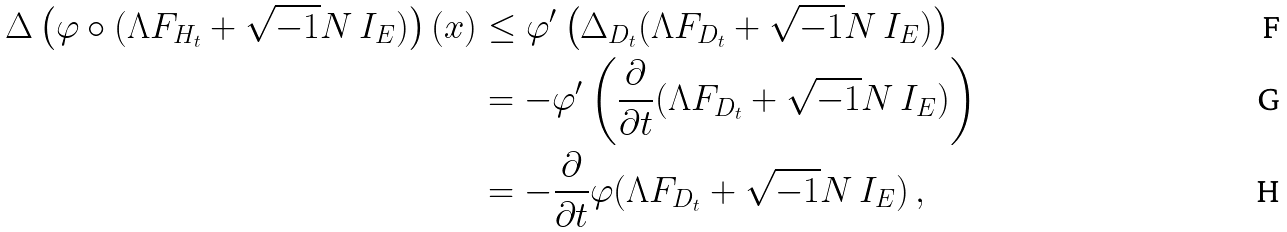<formula> <loc_0><loc_0><loc_500><loc_500>\Delta \left ( \varphi \circ ( \Lambda F _ { H _ { t } } + \sqrt { - 1 } N \, { I } _ { E } ) \right ) ( x ) & \leq \varphi ^ { \prime } \left ( \Delta _ { D _ { t } } ( \Lambda F _ { D _ { t } } + \sqrt { - 1 } N \, { I } _ { E } ) \right ) \\ & = - \varphi ^ { \prime } \left ( \frac { \partial } { \partial t } ( \Lambda F _ { D _ { t } } + \sqrt { - 1 } N \, { I } _ { E } ) \right ) \\ & = - \frac { \partial } { \partial t } \varphi ( \Lambda F _ { D _ { t } } + \sqrt { - 1 } N \, { I } _ { E } ) \ ,</formula> 